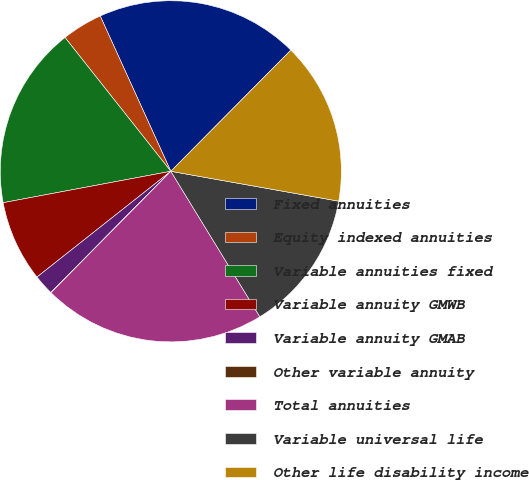Convert chart to OTSL. <chart><loc_0><loc_0><loc_500><loc_500><pie_chart><fcel>Fixed annuities<fcel>Equity indexed annuities<fcel>Variable annuities fixed<fcel>Variable annuity GMWB<fcel>Variable annuity GMAB<fcel>Other variable annuity<fcel>Total annuities<fcel>Variable universal life<fcel>Other life disability income<nl><fcel>19.22%<fcel>3.86%<fcel>17.3%<fcel>7.7%<fcel>1.94%<fcel>0.02%<fcel>21.14%<fcel>13.46%<fcel>15.38%<nl></chart> 